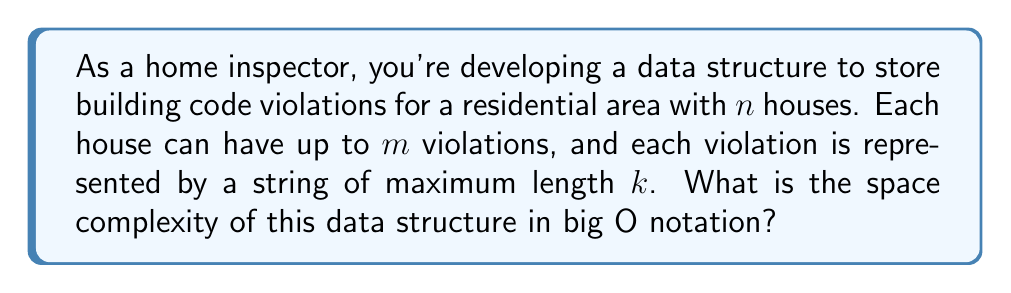Could you help me with this problem? Let's break this down step-by-step:

1) We have $n$ houses in total.

2) For each house, we need to store up to $m$ violations.

3) Each violation is represented by a string of maximum length $k$.

4) In the worst case, every house has the maximum number of violations, and each violation description uses the maximum string length.

5) For a single violation:
   - The space required is $O(k)$, as we need to store a string of length $k$.

6) For a single house:
   - We have up to $m$ violations, each taking $O(k)$ space.
   - So, the space for one house is $O(m \cdot k)$.

7) For all $n$ houses:
   - We multiply the space for one house by $n$.
   - This gives us: $O(n \cdot m \cdot k)$.

Therefore, the overall space complexity of the data structure is $O(n \cdot m \cdot k)$.
Answer: $O(n \cdot m \cdot k)$ 